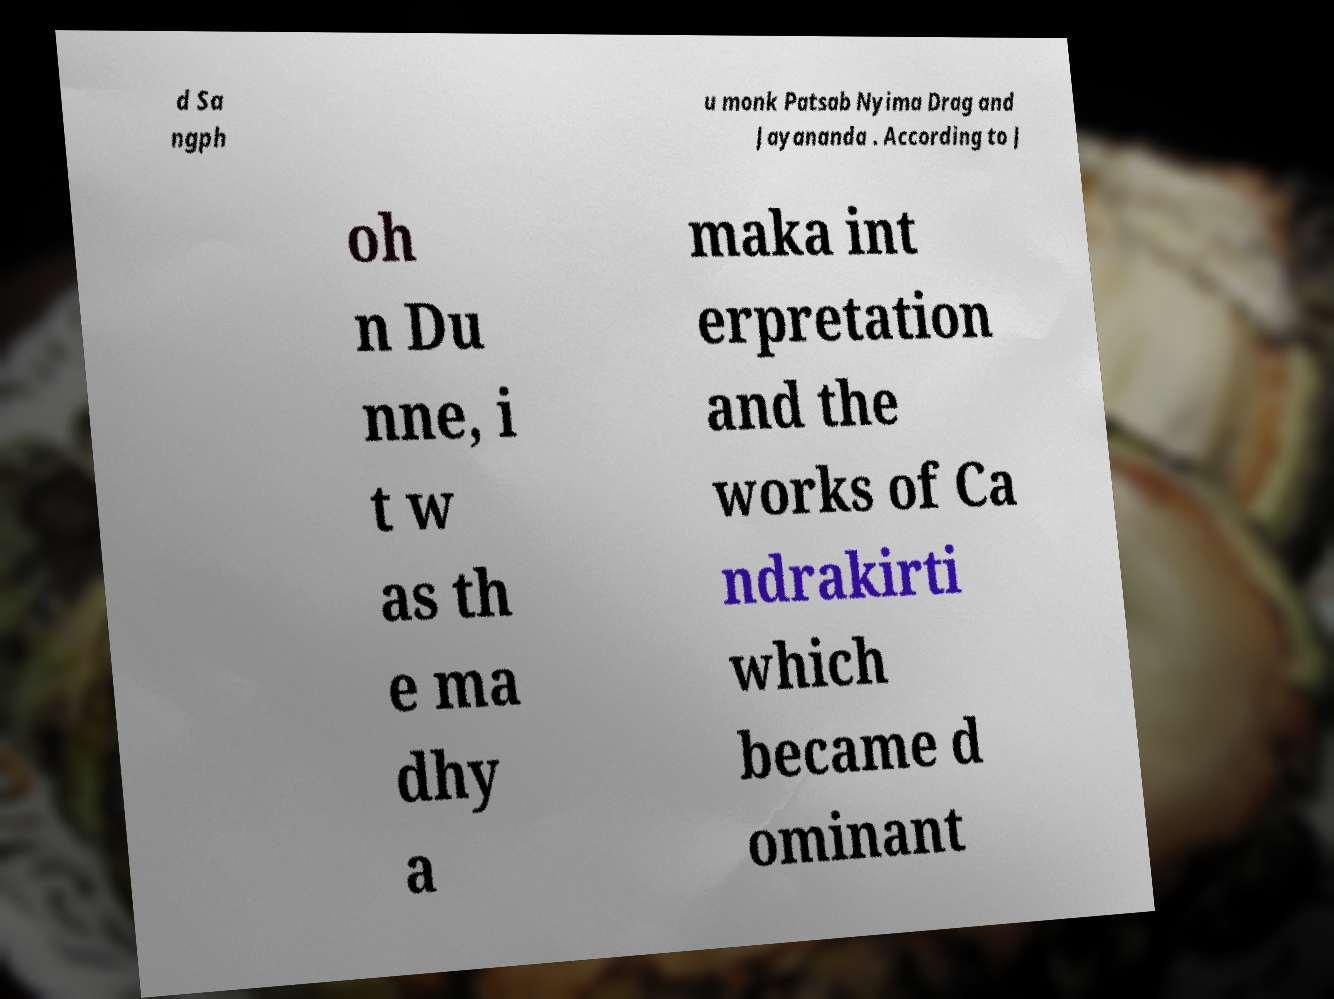Please identify and transcribe the text found in this image. d Sa ngph u monk Patsab Nyima Drag and Jayananda . According to J oh n Du nne, i t w as th e ma dhy a maka int erpretation and the works of Ca ndrakirti which became d ominant 